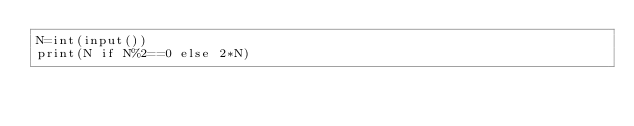Convert code to text. <code><loc_0><loc_0><loc_500><loc_500><_Python_>N=int(input())
print(N if N%2==0 else 2*N)</code> 